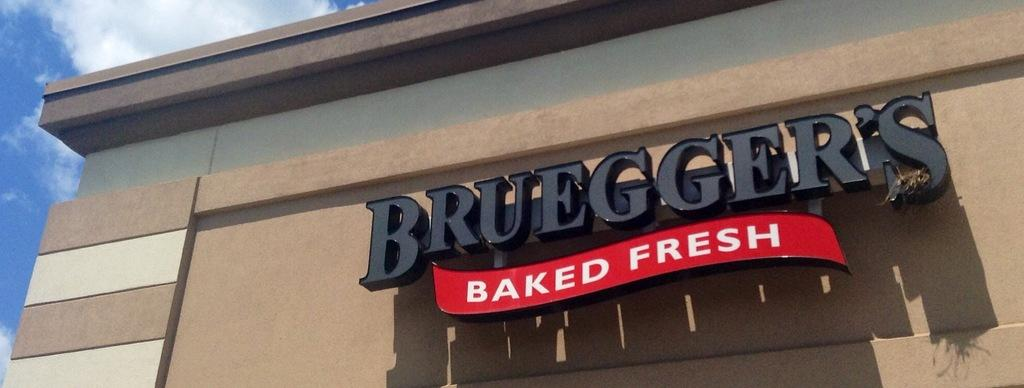What is present on the wall in the image? There is a name board on the wall. What is attached to the name board? There is a red label with something written on it. What can be seen at the top of the image? The sky is visible at the top of the image. What is the condition of the sky in the image? There are clouds in the sky. What type of wilderness can be seen in the background of the image? There is no wilderness visible in the image; it only features a wall with a name board and a sky with clouds. How many jars are present on the wall in the image? There are no jars present on the wall in the image; it only features a name board and a red label. 